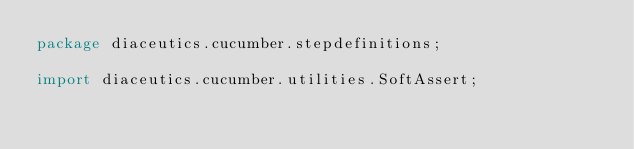Convert code to text. <code><loc_0><loc_0><loc_500><loc_500><_Java_>package diaceutics.cucumber.stepdefinitions;

import diaceutics.cucumber.utilities.SoftAssert;</code> 